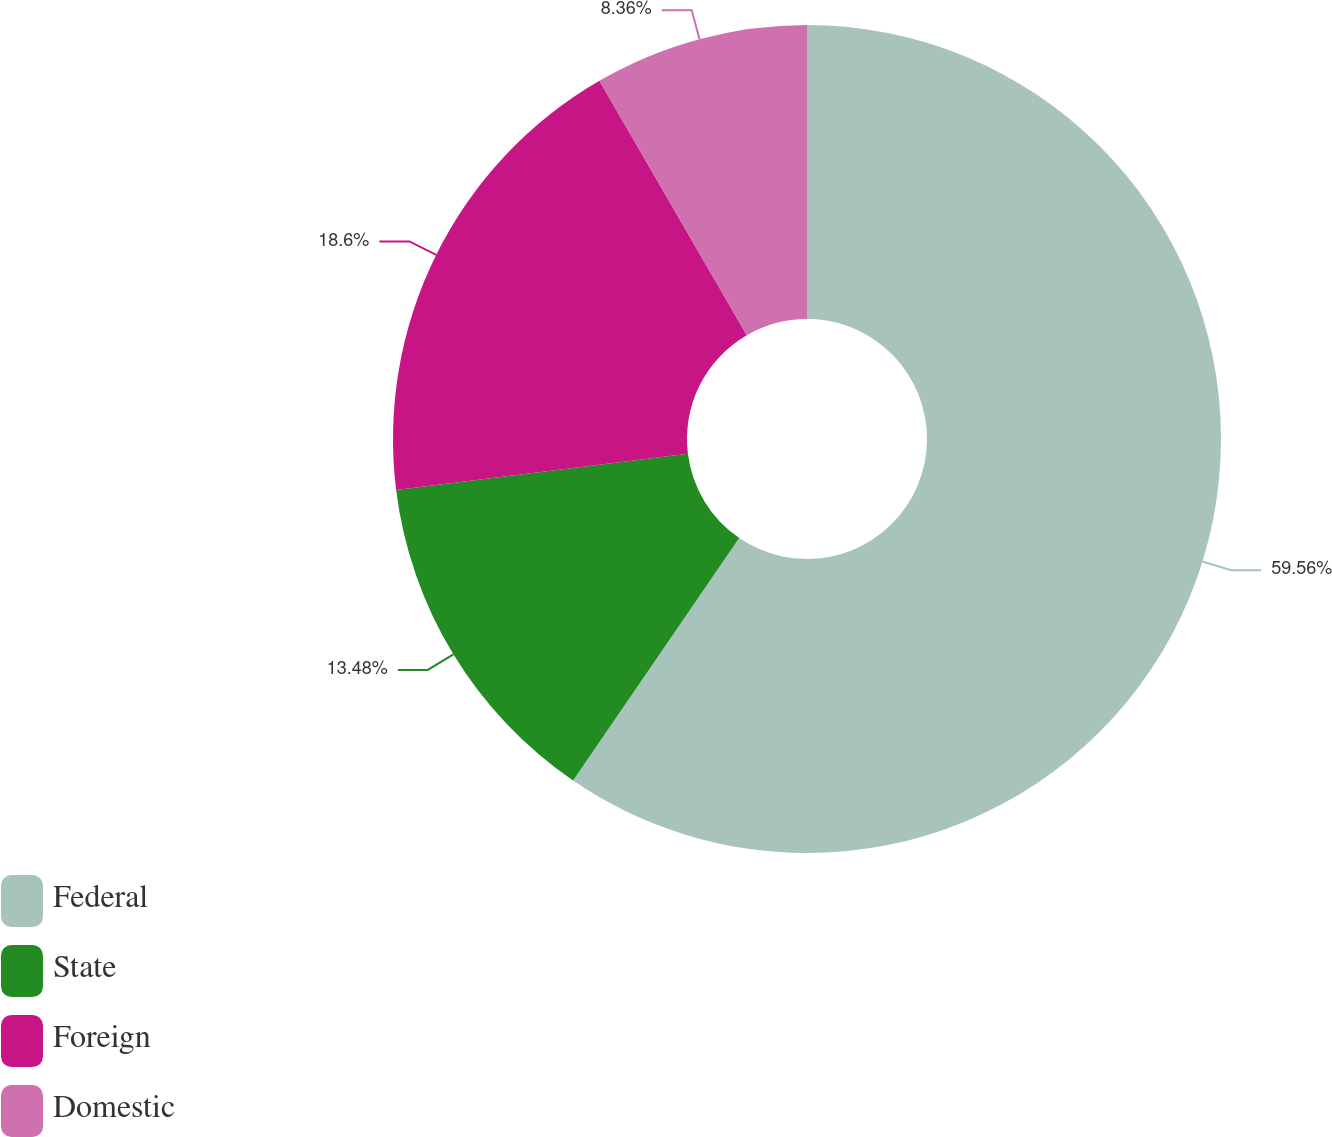Convert chart. <chart><loc_0><loc_0><loc_500><loc_500><pie_chart><fcel>Federal<fcel>State<fcel>Foreign<fcel>Domestic<nl><fcel>59.55%<fcel>13.48%<fcel>18.6%<fcel>8.36%<nl></chart> 